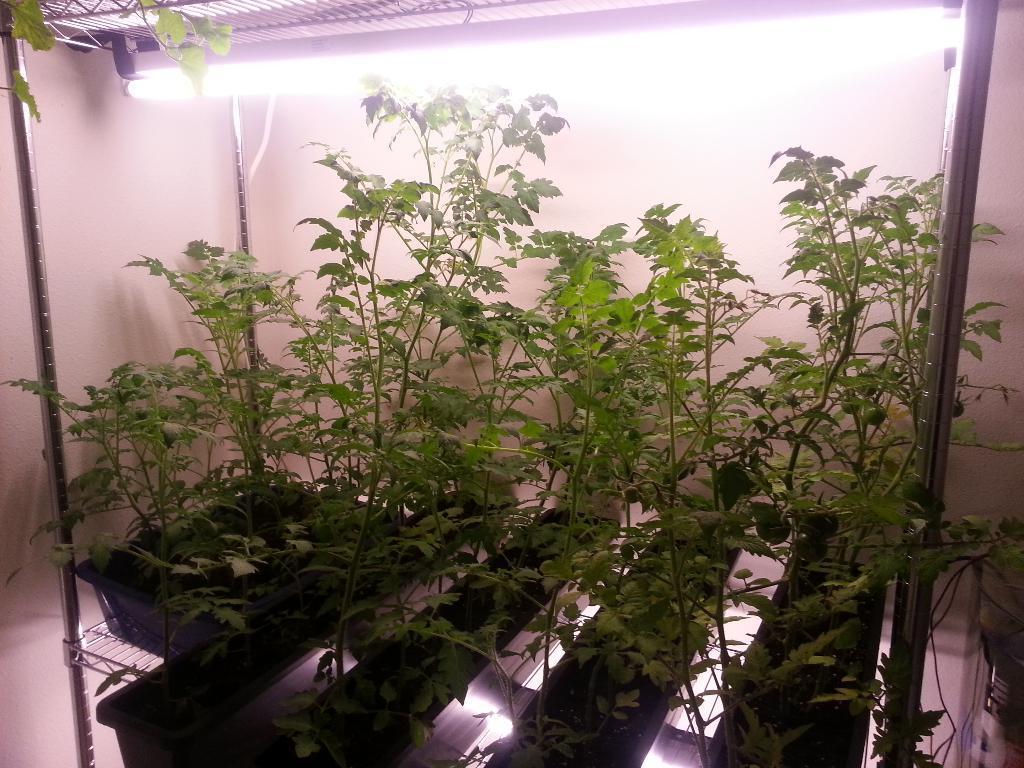In one or two sentences, can you explain what this image depicts? In this image I can see plant pots. There are metal rods and there is a light at the top. There is a wall at the back. 